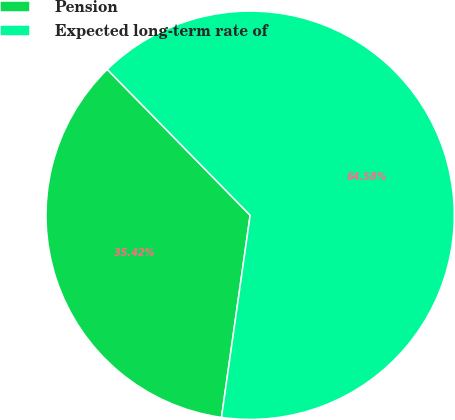<chart> <loc_0><loc_0><loc_500><loc_500><pie_chart><fcel>Pension<fcel>Expected long-term rate of<nl><fcel>35.42%<fcel>64.58%<nl></chart> 